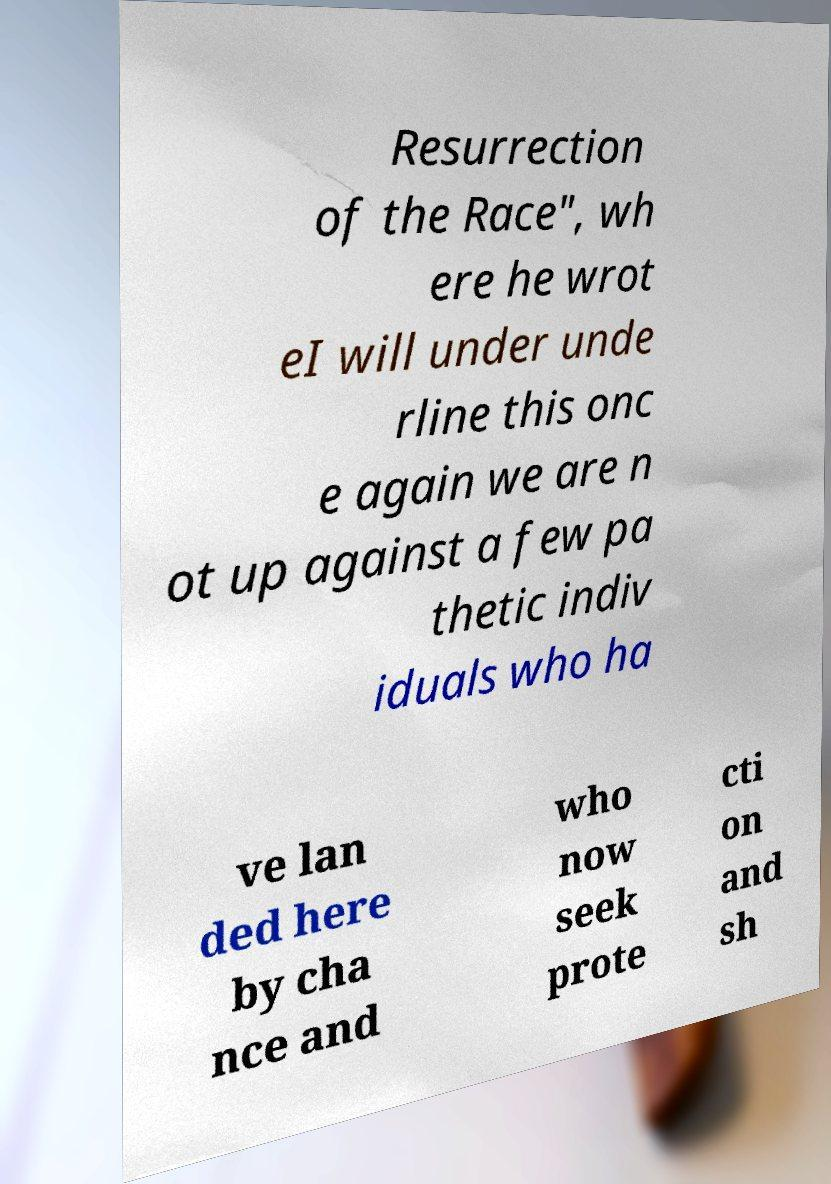There's text embedded in this image that I need extracted. Can you transcribe it verbatim? Resurrection of the Race", wh ere he wrot eI will under unde rline this onc e again we are n ot up against a few pa thetic indiv iduals who ha ve lan ded here by cha nce and who now seek prote cti on and sh 